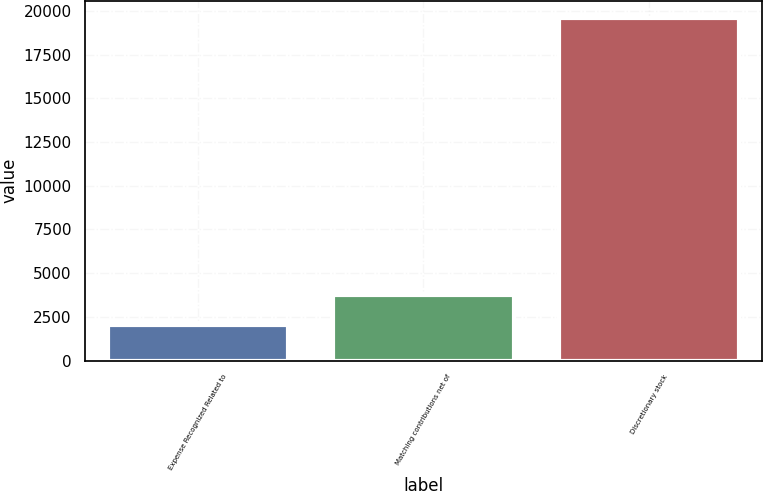Convert chart. <chart><loc_0><loc_0><loc_500><loc_500><bar_chart><fcel>Expense Recognized Related to<fcel>Matching contributions net of<fcel>Discretionary stock<nl><fcel>2007<fcel>3765.7<fcel>19594<nl></chart> 